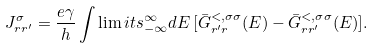Convert formula to latex. <formula><loc_0><loc_0><loc_500><loc_500>J _ { r r ^ { \prime } } ^ { \sigma } = \frac { e \gamma } { h } \int \lim i t s _ { - \infty } ^ { \infty } d E \, [ \bar { G } ^ { < , \sigma \sigma } _ { r ^ { \prime } r } ( E ) - \bar { G } ^ { < , \sigma \sigma } _ { r r ^ { \prime } } ( E ) ] .</formula> 